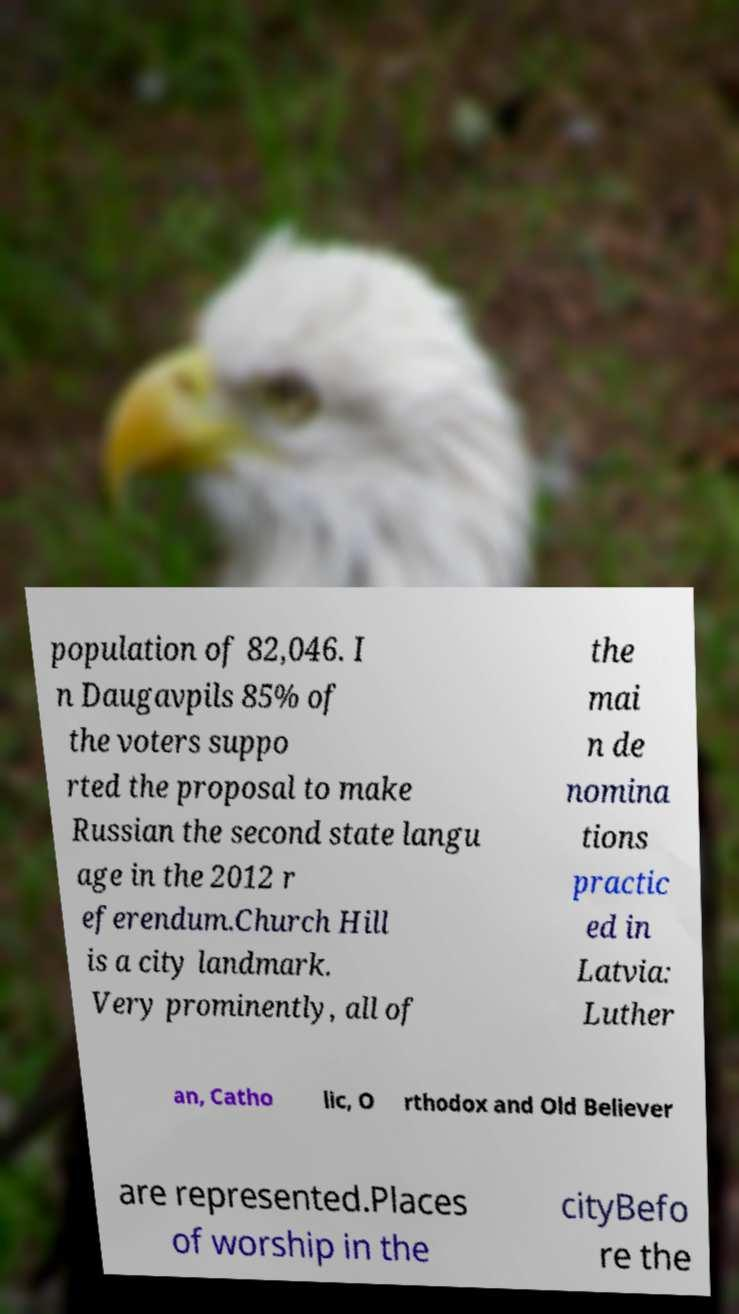There's text embedded in this image that I need extracted. Can you transcribe it verbatim? population of 82,046. I n Daugavpils 85% of the voters suppo rted the proposal to make Russian the second state langu age in the 2012 r eferendum.Church Hill is a city landmark. Very prominently, all of the mai n de nomina tions practic ed in Latvia: Luther an, Catho lic, O rthodox and Old Believer are represented.Places of worship in the cityBefo re the 